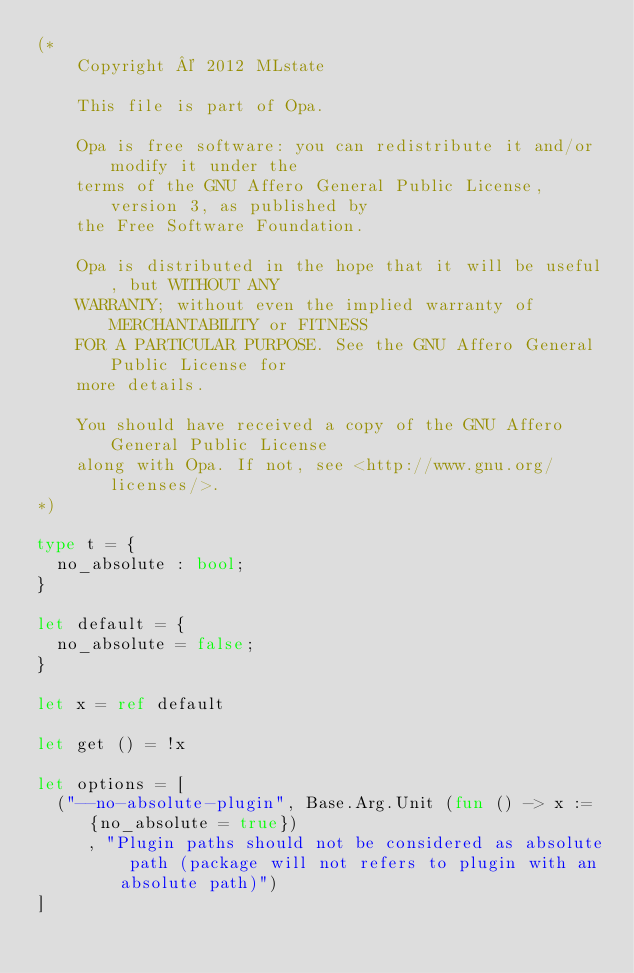<code> <loc_0><loc_0><loc_500><loc_500><_OCaml_>(*
    Copyright © 2012 MLstate

    This file is part of Opa.

    Opa is free software: you can redistribute it and/or modify it under the
    terms of the GNU Affero General Public License, version 3, as published by
    the Free Software Foundation.

    Opa is distributed in the hope that it will be useful, but WITHOUT ANY
    WARRANTY; without even the implied warranty of MERCHANTABILITY or FITNESS
    FOR A PARTICULAR PURPOSE. See the GNU Affero General Public License for
    more details.

    You should have received a copy of the GNU Affero General Public License
    along with Opa. If not, see <http://www.gnu.org/licenses/>.
*)

type t = {
  no_absolute : bool;
}

let default = {
  no_absolute = false;
}

let x = ref default

let get () = !x

let options = [
  ("--no-absolute-plugin", Base.Arg.Unit (fun () -> x := {no_absolute = true})
     , "Plugin paths should not be considered as absolute path (package will not refers to plugin with an absolute path)")
]
</code> 